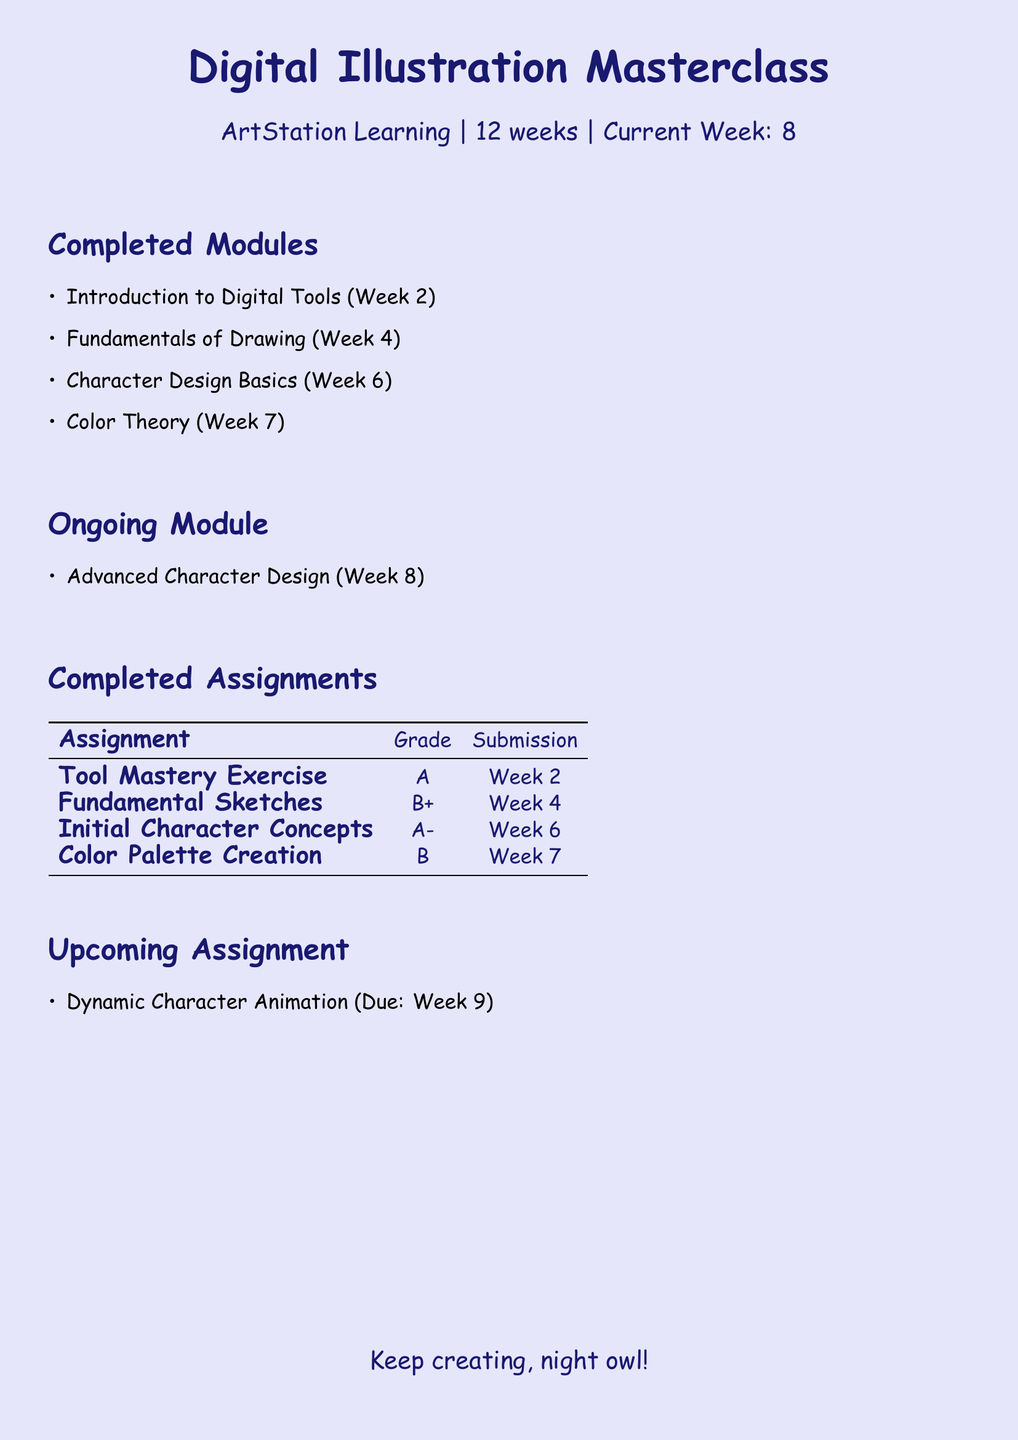What is the title of the course? The title of the course is the first line of the document, which states the overall focus.
Answer: Digital Illustration Masterclass How many weeks is the course duration? The duration of the course is specified shortly after the title, indicating the overall timeline.
Answer: 12 weeks Which week is currently in progress? The current week is explicitly mentioned in the document as part of the course tracking.
Answer: 8 What is the grade for the “Initial Character Concepts” assignment? The grade for this specific assignment can be found in the completed assignments section of the document.
Answer: A- What module is currently ongoing? The ongoing module is listed separately and provides insights into the current area of focus for the student.
Answer: Advanced Character Design What is the grade for the “Color Palette Creation” assignment? The grade for this assignment is located in the same table as other completed assignments, providing consistency in tracking progress.
Answer: B What is the due date for the upcoming assignment? The due date is specified in the upcoming assignment section, indicating when the next task must be completed.
Answer: Week 9 How many assignments have been completed so far? By counting the assignments listed under completed assignments, we can determine the total number of tasks that have been finished.
Answer: 4 What color is used for the document background? The background color is noted as part of the aesthetic choices made in the document settings.
Answer: Lavender 